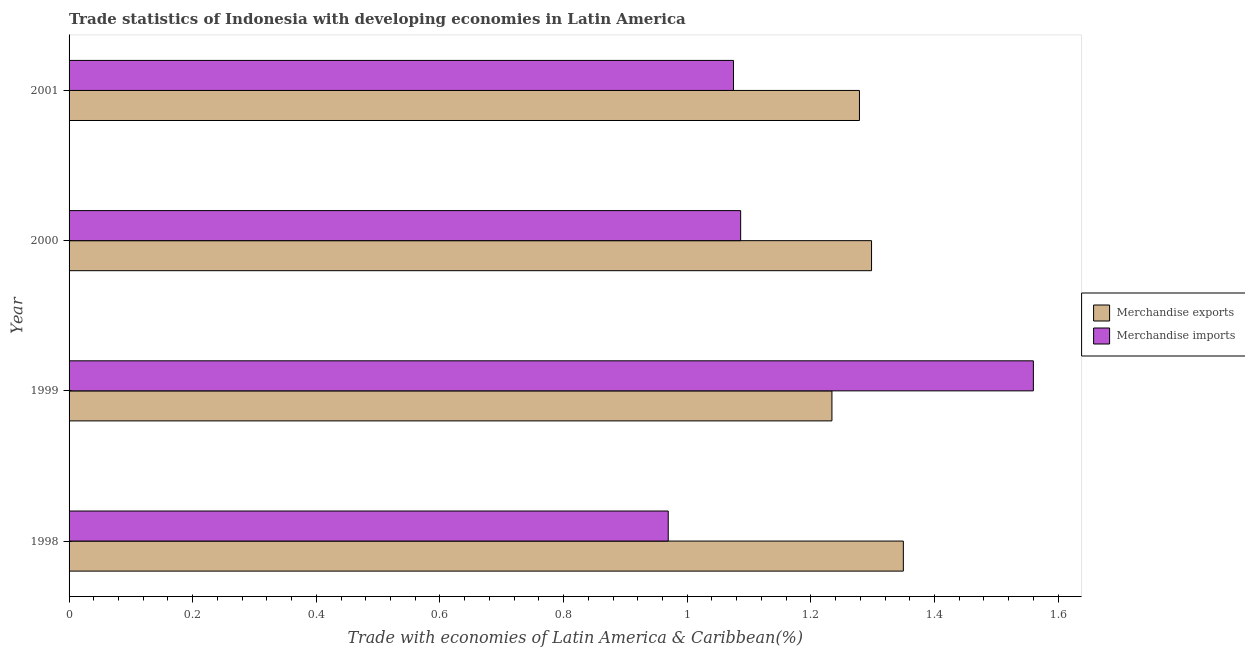How many different coloured bars are there?
Provide a short and direct response. 2. What is the label of the 3rd group of bars from the top?
Your response must be concise. 1999. What is the merchandise exports in 2001?
Offer a terse response. 1.28. Across all years, what is the maximum merchandise exports?
Your answer should be compact. 1.35. Across all years, what is the minimum merchandise imports?
Offer a very short reply. 0.97. In which year was the merchandise imports maximum?
Your answer should be very brief. 1999. What is the total merchandise exports in the graph?
Keep it short and to the point. 5.16. What is the difference between the merchandise imports in 1999 and that in 2001?
Your answer should be very brief. 0.48. What is the difference between the merchandise imports in 1998 and the merchandise exports in 2001?
Provide a short and direct response. -0.31. What is the average merchandise imports per year?
Ensure brevity in your answer.  1.17. In the year 1998, what is the difference between the merchandise imports and merchandise exports?
Your answer should be very brief. -0.38. Is the merchandise imports in 1999 less than that in 2000?
Offer a terse response. No. Is the difference between the merchandise exports in 1999 and 2000 greater than the difference between the merchandise imports in 1999 and 2000?
Your answer should be compact. No. What is the difference between the highest and the second highest merchandise imports?
Make the answer very short. 0.47. What is the difference between the highest and the lowest merchandise exports?
Provide a short and direct response. 0.12. What does the 2nd bar from the bottom in 1999 represents?
Provide a short and direct response. Merchandise imports. How many years are there in the graph?
Provide a succinct answer. 4. Are the values on the major ticks of X-axis written in scientific E-notation?
Give a very brief answer. No. Where does the legend appear in the graph?
Your answer should be compact. Center right. What is the title of the graph?
Your answer should be compact. Trade statistics of Indonesia with developing economies in Latin America. What is the label or title of the X-axis?
Your answer should be compact. Trade with economies of Latin America & Caribbean(%). What is the label or title of the Y-axis?
Ensure brevity in your answer.  Year. What is the Trade with economies of Latin America & Caribbean(%) of Merchandise exports in 1998?
Offer a terse response. 1.35. What is the Trade with economies of Latin America & Caribbean(%) of Merchandise imports in 1998?
Provide a succinct answer. 0.97. What is the Trade with economies of Latin America & Caribbean(%) in Merchandise exports in 1999?
Ensure brevity in your answer.  1.23. What is the Trade with economies of Latin America & Caribbean(%) in Merchandise imports in 1999?
Provide a succinct answer. 1.56. What is the Trade with economies of Latin America & Caribbean(%) in Merchandise exports in 2000?
Your answer should be compact. 1.3. What is the Trade with economies of Latin America & Caribbean(%) of Merchandise imports in 2000?
Your answer should be very brief. 1.09. What is the Trade with economies of Latin America & Caribbean(%) of Merchandise exports in 2001?
Keep it short and to the point. 1.28. What is the Trade with economies of Latin America & Caribbean(%) of Merchandise imports in 2001?
Give a very brief answer. 1.07. Across all years, what is the maximum Trade with economies of Latin America & Caribbean(%) of Merchandise exports?
Offer a terse response. 1.35. Across all years, what is the maximum Trade with economies of Latin America & Caribbean(%) in Merchandise imports?
Make the answer very short. 1.56. Across all years, what is the minimum Trade with economies of Latin America & Caribbean(%) in Merchandise exports?
Your answer should be compact. 1.23. Across all years, what is the minimum Trade with economies of Latin America & Caribbean(%) in Merchandise imports?
Your answer should be compact. 0.97. What is the total Trade with economies of Latin America & Caribbean(%) of Merchandise exports in the graph?
Give a very brief answer. 5.16. What is the total Trade with economies of Latin America & Caribbean(%) in Merchandise imports in the graph?
Your response must be concise. 4.69. What is the difference between the Trade with economies of Latin America & Caribbean(%) in Merchandise exports in 1998 and that in 1999?
Ensure brevity in your answer.  0.12. What is the difference between the Trade with economies of Latin America & Caribbean(%) of Merchandise imports in 1998 and that in 1999?
Your response must be concise. -0.59. What is the difference between the Trade with economies of Latin America & Caribbean(%) in Merchandise exports in 1998 and that in 2000?
Keep it short and to the point. 0.05. What is the difference between the Trade with economies of Latin America & Caribbean(%) in Merchandise imports in 1998 and that in 2000?
Your response must be concise. -0.12. What is the difference between the Trade with economies of Latin America & Caribbean(%) in Merchandise exports in 1998 and that in 2001?
Keep it short and to the point. 0.07. What is the difference between the Trade with economies of Latin America & Caribbean(%) of Merchandise imports in 1998 and that in 2001?
Your response must be concise. -0.11. What is the difference between the Trade with economies of Latin America & Caribbean(%) of Merchandise exports in 1999 and that in 2000?
Offer a very short reply. -0.06. What is the difference between the Trade with economies of Latin America & Caribbean(%) in Merchandise imports in 1999 and that in 2000?
Offer a terse response. 0.47. What is the difference between the Trade with economies of Latin America & Caribbean(%) in Merchandise exports in 1999 and that in 2001?
Offer a very short reply. -0.04. What is the difference between the Trade with economies of Latin America & Caribbean(%) of Merchandise imports in 1999 and that in 2001?
Your response must be concise. 0.49. What is the difference between the Trade with economies of Latin America & Caribbean(%) in Merchandise exports in 2000 and that in 2001?
Give a very brief answer. 0.02. What is the difference between the Trade with economies of Latin America & Caribbean(%) in Merchandise imports in 2000 and that in 2001?
Provide a short and direct response. 0.01. What is the difference between the Trade with economies of Latin America & Caribbean(%) in Merchandise exports in 1998 and the Trade with economies of Latin America & Caribbean(%) in Merchandise imports in 1999?
Make the answer very short. -0.21. What is the difference between the Trade with economies of Latin America & Caribbean(%) of Merchandise exports in 1998 and the Trade with economies of Latin America & Caribbean(%) of Merchandise imports in 2000?
Keep it short and to the point. 0.26. What is the difference between the Trade with economies of Latin America & Caribbean(%) in Merchandise exports in 1998 and the Trade with economies of Latin America & Caribbean(%) in Merchandise imports in 2001?
Your answer should be very brief. 0.27. What is the difference between the Trade with economies of Latin America & Caribbean(%) in Merchandise exports in 1999 and the Trade with economies of Latin America & Caribbean(%) in Merchandise imports in 2000?
Make the answer very short. 0.15. What is the difference between the Trade with economies of Latin America & Caribbean(%) in Merchandise exports in 1999 and the Trade with economies of Latin America & Caribbean(%) in Merchandise imports in 2001?
Give a very brief answer. 0.16. What is the difference between the Trade with economies of Latin America & Caribbean(%) in Merchandise exports in 2000 and the Trade with economies of Latin America & Caribbean(%) in Merchandise imports in 2001?
Offer a terse response. 0.22. What is the average Trade with economies of Latin America & Caribbean(%) in Merchandise exports per year?
Your answer should be compact. 1.29. What is the average Trade with economies of Latin America & Caribbean(%) in Merchandise imports per year?
Your answer should be very brief. 1.17. In the year 1998, what is the difference between the Trade with economies of Latin America & Caribbean(%) of Merchandise exports and Trade with economies of Latin America & Caribbean(%) of Merchandise imports?
Keep it short and to the point. 0.38. In the year 1999, what is the difference between the Trade with economies of Latin America & Caribbean(%) of Merchandise exports and Trade with economies of Latin America & Caribbean(%) of Merchandise imports?
Your response must be concise. -0.33. In the year 2000, what is the difference between the Trade with economies of Latin America & Caribbean(%) of Merchandise exports and Trade with economies of Latin America & Caribbean(%) of Merchandise imports?
Your answer should be very brief. 0.21. In the year 2001, what is the difference between the Trade with economies of Latin America & Caribbean(%) of Merchandise exports and Trade with economies of Latin America & Caribbean(%) of Merchandise imports?
Your response must be concise. 0.2. What is the ratio of the Trade with economies of Latin America & Caribbean(%) of Merchandise exports in 1998 to that in 1999?
Provide a short and direct response. 1.09. What is the ratio of the Trade with economies of Latin America & Caribbean(%) in Merchandise imports in 1998 to that in 1999?
Your answer should be very brief. 0.62. What is the ratio of the Trade with economies of Latin America & Caribbean(%) in Merchandise exports in 1998 to that in 2000?
Your answer should be compact. 1.04. What is the ratio of the Trade with economies of Latin America & Caribbean(%) in Merchandise imports in 1998 to that in 2000?
Make the answer very short. 0.89. What is the ratio of the Trade with economies of Latin America & Caribbean(%) of Merchandise exports in 1998 to that in 2001?
Give a very brief answer. 1.06. What is the ratio of the Trade with economies of Latin America & Caribbean(%) in Merchandise imports in 1998 to that in 2001?
Offer a very short reply. 0.9. What is the ratio of the Trade with economies of Latin America & Caribbean(%) in Merchandise exports in 1999 to that in 2000?
Your answer should be compact. 0.95. What is the ratio of the Trade with economies of Latin America & Caribbean(%) in Merchandise imports in 1999 to that in 2000?
Make the answer very short. 1.44. What is the ratio of the Trade with economies of Latin America & Caribbean(%) in Merchandise exports in 1999 to that in 2001?
Your answer should be compact. 0.97. What is the ratio of the Trade with economies of Latin America & Caribbean(%) in Merchandise imports in 1999 to that in 2001?
Give a very brief answer. 1.45. What is the ratio of the Trade with economies of Latin America & Caribbean(%) in Merchandise exports in 2000 to that in 2001?
Keep it short and to the point. 1.02. What is the ratio of the Trade with economies of Latin America & Caribbean(%) of Merchandise imports in 2000 to that in 2001?
Your response must be concise. 1.01. What is the difference between the highest and the second highest Trade with economies of Latin America & Caribbean(%) of Merchandise exports?
Offer a terse response. 0.05. What is the difference between the highest and the second highest Trade with economies of Latin America & Caribbean(%) in Merchandise imports?
Offer a terse response. 0.47. What is the difference between the highest and the lowest Trade with economies of Latin America & Caribbean(%) in Merchandise exports?
Your answer should be very brief. 0.12. What is the difference between the highest and the lowest Trade with economies of Latin America & Caribbean(%) in Merchandise imports?
Offer a terse response. 0.59. 